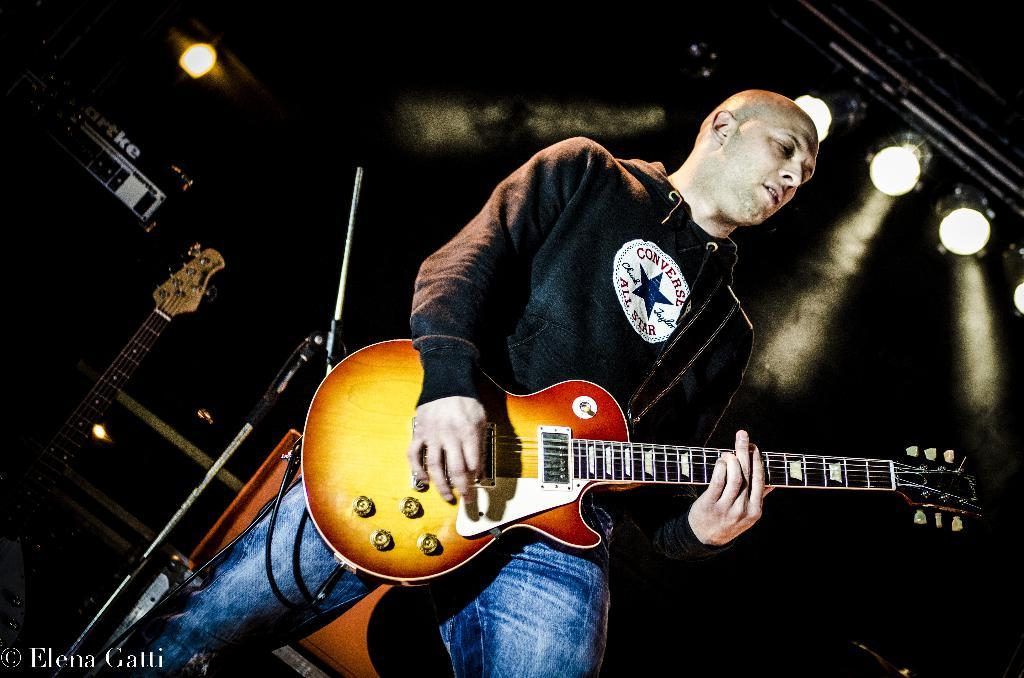What is the man in the image doing? The man is playing a guitar. How is the man positioned in the image? The man is standing. What other items related to music can be seen in the image? There is a mic stand and a guitar in the background of the image. What can be seen in the background that might indicate a performance setting? There are lights in the background of the image. How many beds are visible in the image? There are no beds present in the image. What type of cast is on the man's arm in the image? There is no cast on the man's arm in the image; he is playing a guitar without any visible injuries or casts. 